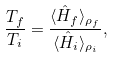<formula> <loc_0><loc_0><loc_500><loc_500>\frac { T _ { f } } { T _ { i } } = \frac { \langle \hat { H } _ { f } \rangle _ { \rho _ { f } } } { \langle \hat { H } _ { i } \rangle _ { \rho _ { i } } } ,</formula> 